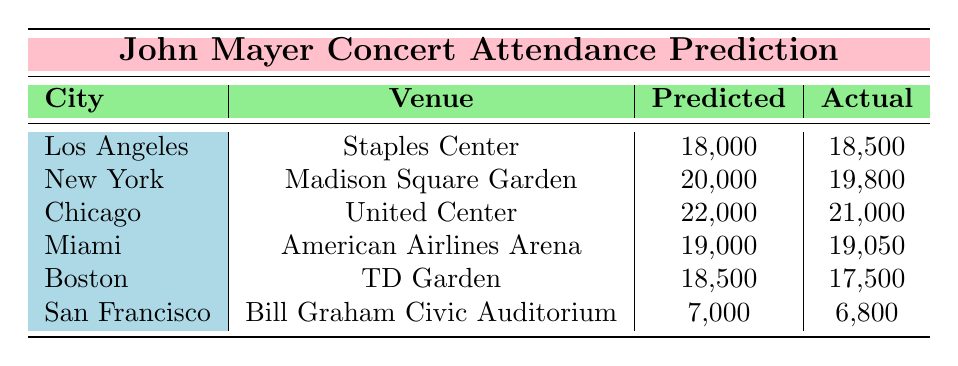What is the actual attendance for the concert in Los Angeles? The table shows the actual attendance for Los Angeles at the Staples Center as 18500.
Answer: 18500 Which city had the highest predicted attendance? By comparing the predicted attendance values, Chicago had the highest with 22000.
Answer: Chicago What is the difference between the predicted and actual attendance in Miami? The predicted attendance is 19000 and the actual attendance is 19050. The difference is 19050 - 19000 = 50.
Answer: 50 Did the predicted attendance exceed the actual attendance for the Boston concert? The predicted attendance for Boston is 18500 and the actual attendance is 17500. Since 18500 is greater than 17500, the statement is true.
Answer: Yes What is the average predicted attendance from all the concerts listed? The predicted attendances are 18000, 20000, 22000, 19000, 18500, and 7000. Adding these together gives 18000 + 20000 + 22000 + 19000 + 18500 + 7000 = 114500. Dividing by the number of concerts (6) gives 114500 / 6 = 19083.33, which rounded gives 19083.
Answer: 19083 In which city was the actual attendance less than the predicted attendance? Looking through the table, Boston (predicted 18500, actual 17500) and San Francisco (predicted 7000, actual 6800) have actual attendance lower than predicted.
Answer: Boston and San Francisco What is the total actual attendance for all concerts combined? To calculate the total actual attendance, add together all actual attendances: 18500 + 19800 + 21000 + 19050 + 17500 + 6800 = 107650.
Answer: 107650 Was the concert in New York successful in terms of attendance if the goal was to reach a predicted attendance? The predicted attendance was 20000, but the actual attendance was 19800, which is less than predicted, indicating it was not entirely successful.
Answer: No Which venue had the smallest actual attendance? The actual attendances are 18500, 19800, 21000, 19050, 17500, and 6800. The smallest is 6800 at the Bill Graham Civic Auditorium in San Francisco.
Answer: Bill Graham Civic Auditorium 